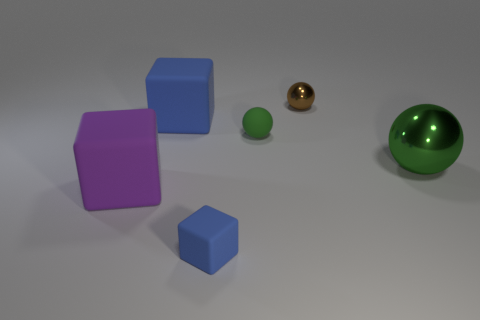Add 1 large rubber cylinders. How many objects exist? 7 Subtract all large cubes. How many cubes are left? 1 Subtract all green balls. How many balls are left? 1 Subtract all purple balls. How many blue cubes are left? 2 Subtract 2 spheres. How many spheres are left? 1 Subtract 2 blue blocks. How many objects are left? 4 Subtract all purple blocks. Subtract all gray spheres. How many blocks are left? 2 Subtract all small brown rubber cylinders. Subtract all green balls. How many objects are left? 4 Add 2 big blue matte objects. How many big blue matte objects are left? 3 Add 3 green metallic balls. How many green metallic balls exist? 4 